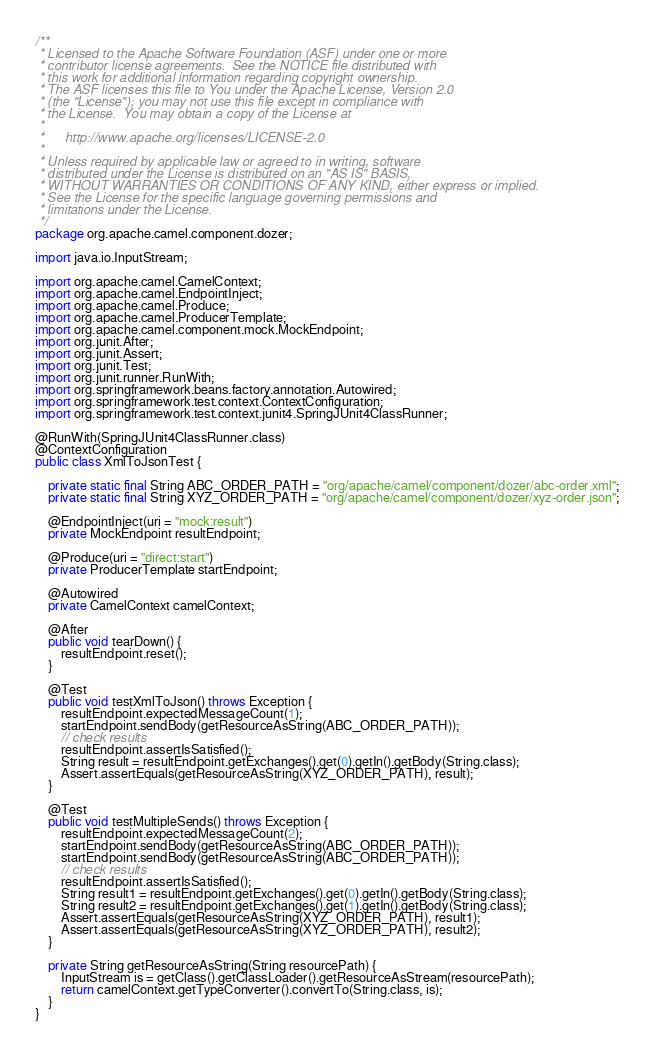<code> <loc_0><loc_0><loc_500><loc_500><_Java_>/**
 * Licensed to the Apache Software Foundation (ASF) under one or more
 * contributor license agreements.  See the NOTICE file distributed with
 * this work for additional information regarding copyright ownership.
 * The ASF licenses this file to You under the Apache License, Version 2.0
 * (the "License"); you may not use this file except in compliance with
 * the License.  You may obtain a copy of the License at
 *
 *      http://www.apache.org/licenses/LICENSE-2.0
 *
 * Unless required by applicable law or agreed to in writing, software
 * distributed under the License is distributed on an "AS IS" BASIS,
 * WITHOUT WARRANTIES OR CONDITIONS OF ANY KIND, either express or implied.
 * See the License for the specific language governing permissions and
 * limitations under the License.
 */
package org.apache.camel.component.dozer;

import java.io.InputStream;

import org.apache.camel.CamelContext;
import org.apache.camel.EndpointInject;
import org.apache.camel.Produce;
import org.apache.camel.ProducerTemplate;
import org.apache.camel.component.mock.MockEndpoint;
import org.junit.After;
import org.junit.Assert;
import org.junit.Test;
import org.junit.runner.RunWith;
import org.springframework.beans.factory.annotation.Autowired;
import org.springframework.test.context.ContextConfiguration;
import org.springframework.test.context.junit4.SpringJUnit4ClassRunner;

@RunWith(SpringJUnit4ClassRunner.class)
@ContextConfiguration
public class XmlToJsonTest {
    
    private static final String ABC_ORDER_PATH = "org/apache/camel/component/dozer/abc-order.xml";
    private static final String XYZ_ORDER_PATH = "org/apache/camel/component/dozer/xyz-order.json";
    
    @EndpointInject(uri = "mock:result")
    private MockEndpoint resultEndpoint;
    
    @Produce(uri = "direct:start")
    private ProducerTemplate startEndpoint;
    
    @Autowired
    private CamelContext camelContext;
    
    @After
    public void tearDown() {
        resultEndpoint.reset();
    }
    
    @Test
    public void testXmlToJson() throws Exception {
        resultEndpoint.expectedMessageCount(1);
        startEndpoint.sendBody(getResourceAsString(ABC_ORDER_PATH));
        // check results
        resultEndpoint.assertIsSatisfied();
        String result = resultEndpoint.getExchanges().get(0).getIn().getBody(String.class);
        Assert.assertEquals(getResourceAsString(XYZ_ORDER_PATH), result);
    }
    
    @Test
    public void testMultipleSends() throws Exception {
        resultEndpoint.expectedMessageCount(2);
        startEndpoint.sendBody(getResourceAsString(ABC_ORDER_PATH));
        startEndpoint.sendBody(getResourceAsString(ABC_ORDER_PATH));
        // check results
        resultEndpoint.assertIsSatisfied();
        String result1 = resultEndpoint.getExchanges().get(0).getIn().getBody(String.class);
        String result2 = resultEndpoint.getExchanges().get(1).getIn().getBody(String.class);
        Assert.assertEquals(getResourceAsString(XYZ_ORDER_PATH), result1);
        Assert.assertEquals(getResourceAsString(XYZ_ORDER_PATH), result2);
    }
    
    private String getResourceAsString(String resourcePath) {
        InputStream is = getClass().getClassLoader().getResourceAsStream(resourcePath);
        return camelContext.getTypeConverter().convertTo(String.class, is);
    }
}
</code> 